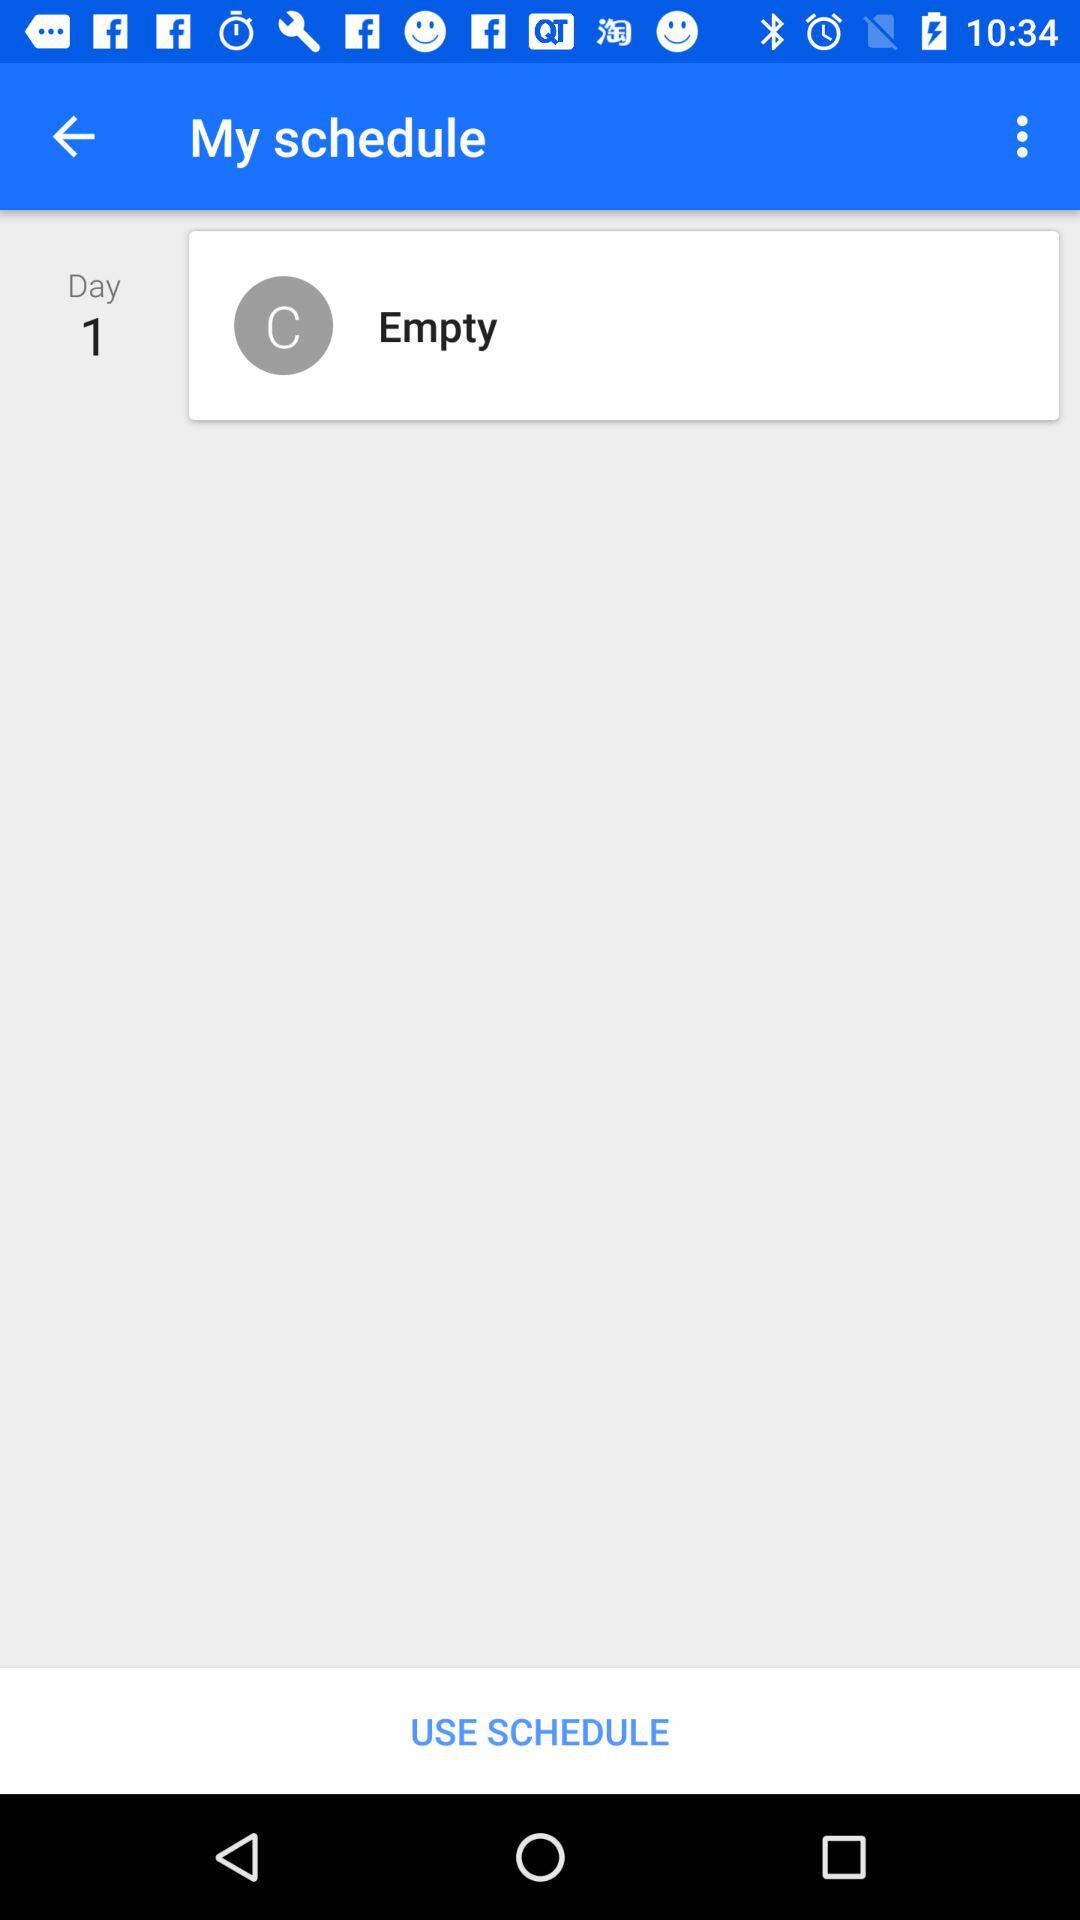How many days are in the schedule?
Answer the question using a single word or phrase. 1 